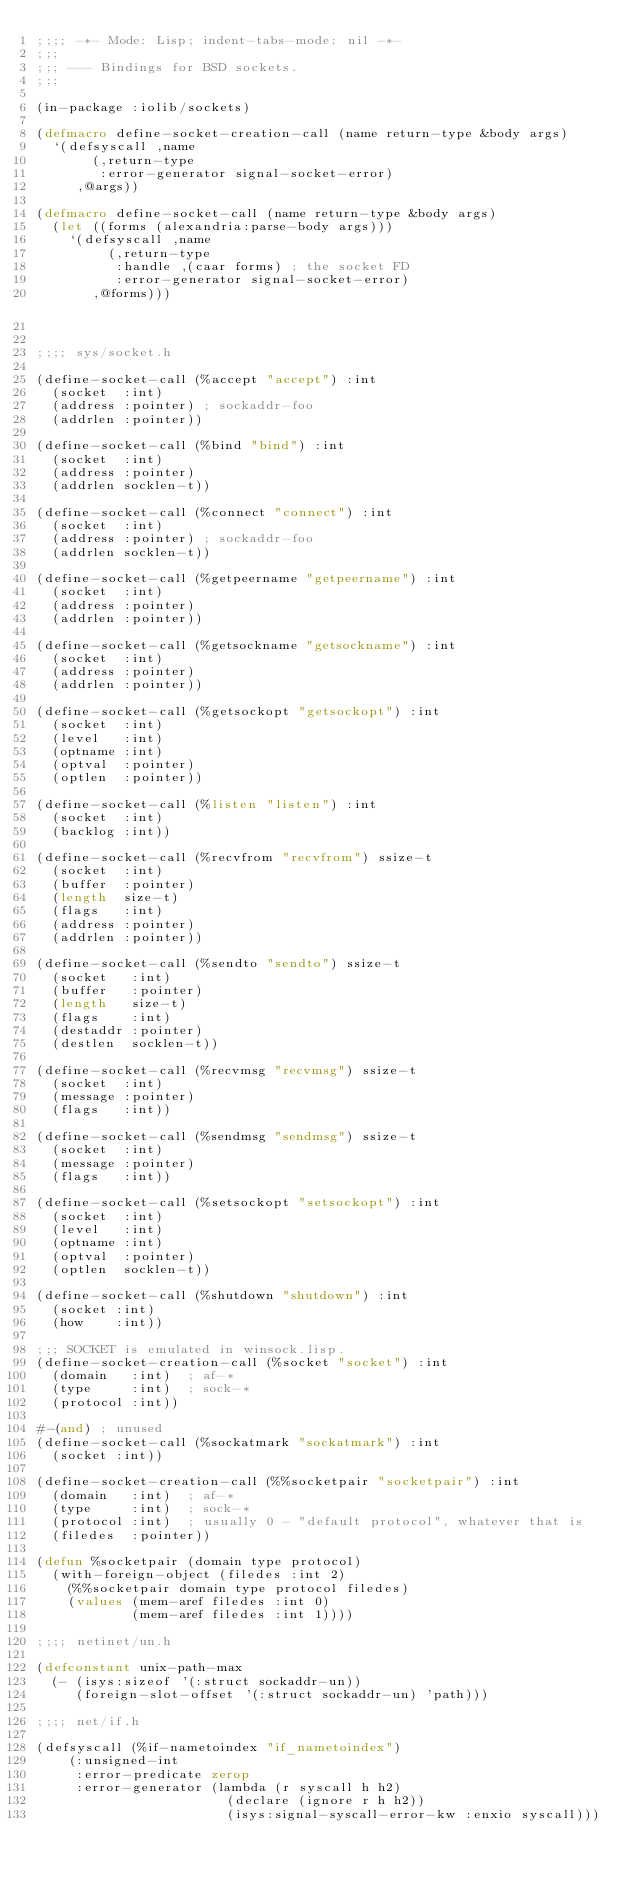Convert code to text. <code><loc_0><loc_0><loc_500><loc_500><_Lisp_>;;;; -*- Mode: Lisp; indent-tabs-mode: nil -*-
;;;
;;; --- Bindings for BSD sockets.
;;;

(in-package :iolib/sockets)

(defmacro define-socket-creation-call (name return-type &body args)
  `(defsyscall ,name
       (,return-type
        :error-generator signal-socket-error)
     ,@args))

(defmacro define-socket-call (name return-type &body args)
  (let ((forms (alexandria:parse-body args)))
    `(defsyscall ,name
         (,return-type
          :handle ,(caar forms) ; the socket FD
          :error-generator signal-socket-error)
       ,@forms)))


;;;; sys/socket.h

(define-socket-call (%accept "accept") :int
  (socket  :int)
  (address :pointer) ; sockaddr-foo
  (addrlen :pointer))

(define-socket-call (%bind "bind") :int
  (socket  :int)
  (address :pointer)
  (addrlen socklen-t))

(define-socket-call (%connect "connect") :int
  (socket  :int)
  (address :pointer) ; sockaddr-foo
  (addrlen socklen-t))

(define-socket-call (%getpeername "getpeername") :int
  (socket  :int)
  (address :pointer)
  (addrlen :pointer))

(define-socket-call (%getsockname "getsockname") :int
  (socket  :int)
  (address :pointer)
  (addrlen :pointer))

(define-socket-call (%getsockopt "getsockopt") :int
  (socket  :int)
  (level   :int)
  (optname :int)
  (optval  :pointer)
  (optlen  :pointer))

(define-socket-call (%listen "listen") :int
  (socket  :int)
  (backlog :int))

(define-socket-call (%recvfrom "recvfrom") ssize-t
  (socket  :int)
  (buffer  :pointer)
  (length  size-t)
  (flags   :int)
  (address :pointer)
  (addrlen :pointer))

(define-socket-call (%sendto "sendto") ssize-t
  (socket   :int)
  (buffer   :pointer)
  (length   size-t)
  (flags    :int)
  (destaddr :pointer)
  (destlen  socklen-t))

(define-socket-call (%recvmsg "recvmsg") ssize-t
  (socket  :int)
  (message :pointer)
  (flags   :int))

(define-socket-call (%sendmsg "sendmsg") ssize-t
  (socket  :int)
  (message :pointer)
  (flags   :int))

(define-socket-call (%setsockopt "setsockopt") :int
  (socket  :int)
  (level   :int)
  (optname :int)
  (optval  :pointer)
  (optlen  socklen-t))

(define-socket-call (%shutdown "shutdown") :int
  (socket :int)
  (how    :int))

;;; SOCKET is emulated in winsock.lisp.
(define-socket-creation-call (%socket "socket") :int
  (domain   :int)  ; af-*
  (type     :int)  ; sock-*
  (protocol :int))

#-(and) ; unused
(define-socket-call (%sockatmark "sockatmark") :int
  (socket :int))

(define-socket-creation-call (%%socketpair "socketpair") :int
  (domain   :int)  ; af-*
  (type     :int)  ; sock-*
  (protocol :int)  ; usually 0 - "default protocol", whatever that is
  (filedes  :pointer))

(defun %socketpair (domain type protocol)
  (with-foreign-object (filedes :int 2)
    (%%socketpair domain type protocol filedes)
    (values (mem-aref filedes :int 0)
            (mem-aref filedes :int 1))))

;;;; netinet/un.h

(defconstant unix-path-max
  (- (isys:sizeof '(:struct sockaddr-un))
     (foreign-slot-offset '(:struct sockaddr-un) 'path)))

;;;; net/if.h

(defsyscall (%if-nametoindex "if_nametoindex")
    (:unsigned-int
     :error-predicate zerop
     :error-generator (lambda (r syscall h h2)
                        (declare (ignore r h h2))
                        (isys:signal-syscall-error-kw :enxio syscall)))</code> 